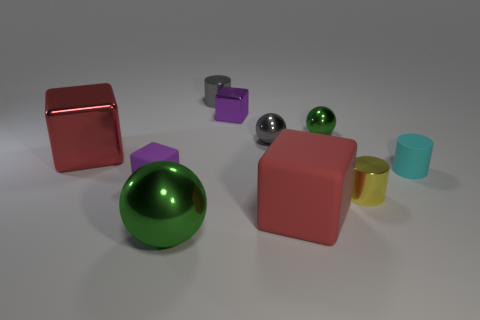Subtract all blocks. How many objects are left? 6 Add 8 yellow things. How many yellow things are left? 9 Add 3 red shiny cubes. How many red shiny cubes exist? 4 Subtract 1 cyan cylinders. How many objects are left? 9 Subtract all large matte things. Subtract all matte blocks. How many objects are left? 7 